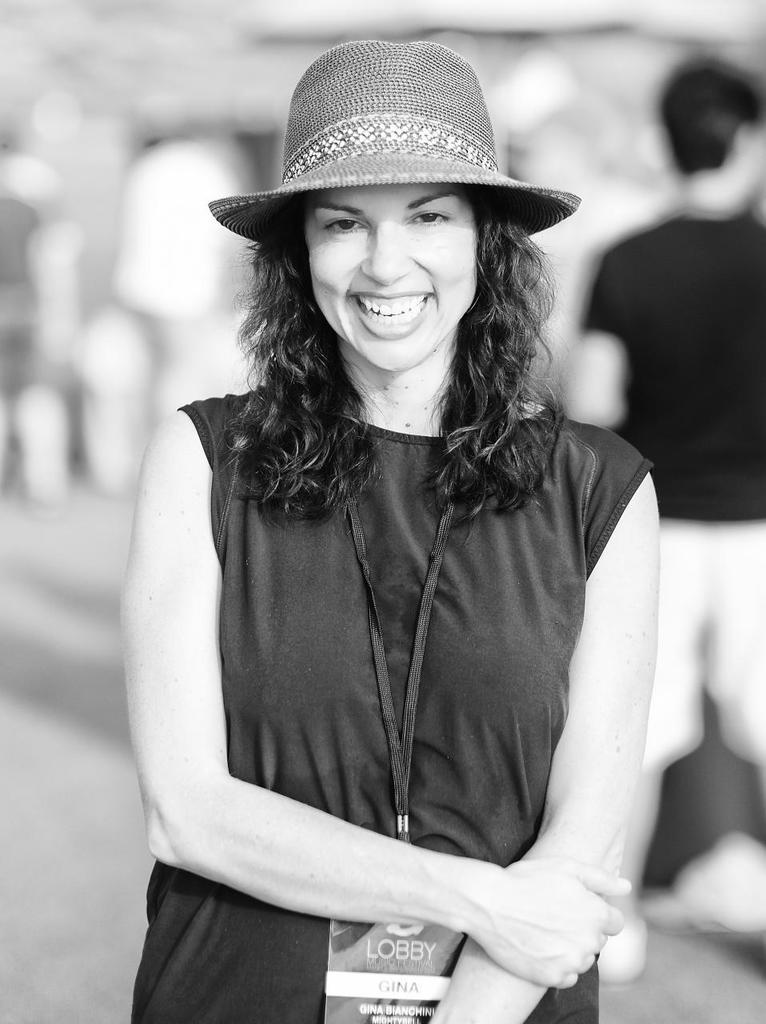Who is the main subject in the image? There is a lady standing in the center of the image. What is the lady wearing on her head? The lady is wearing a hat. Can you describe the man in the image? The man is in the background of the image. What type of coast can be seen in the image? There is no coast visible in the image; it features a lady standing in the center and a man in the background. 